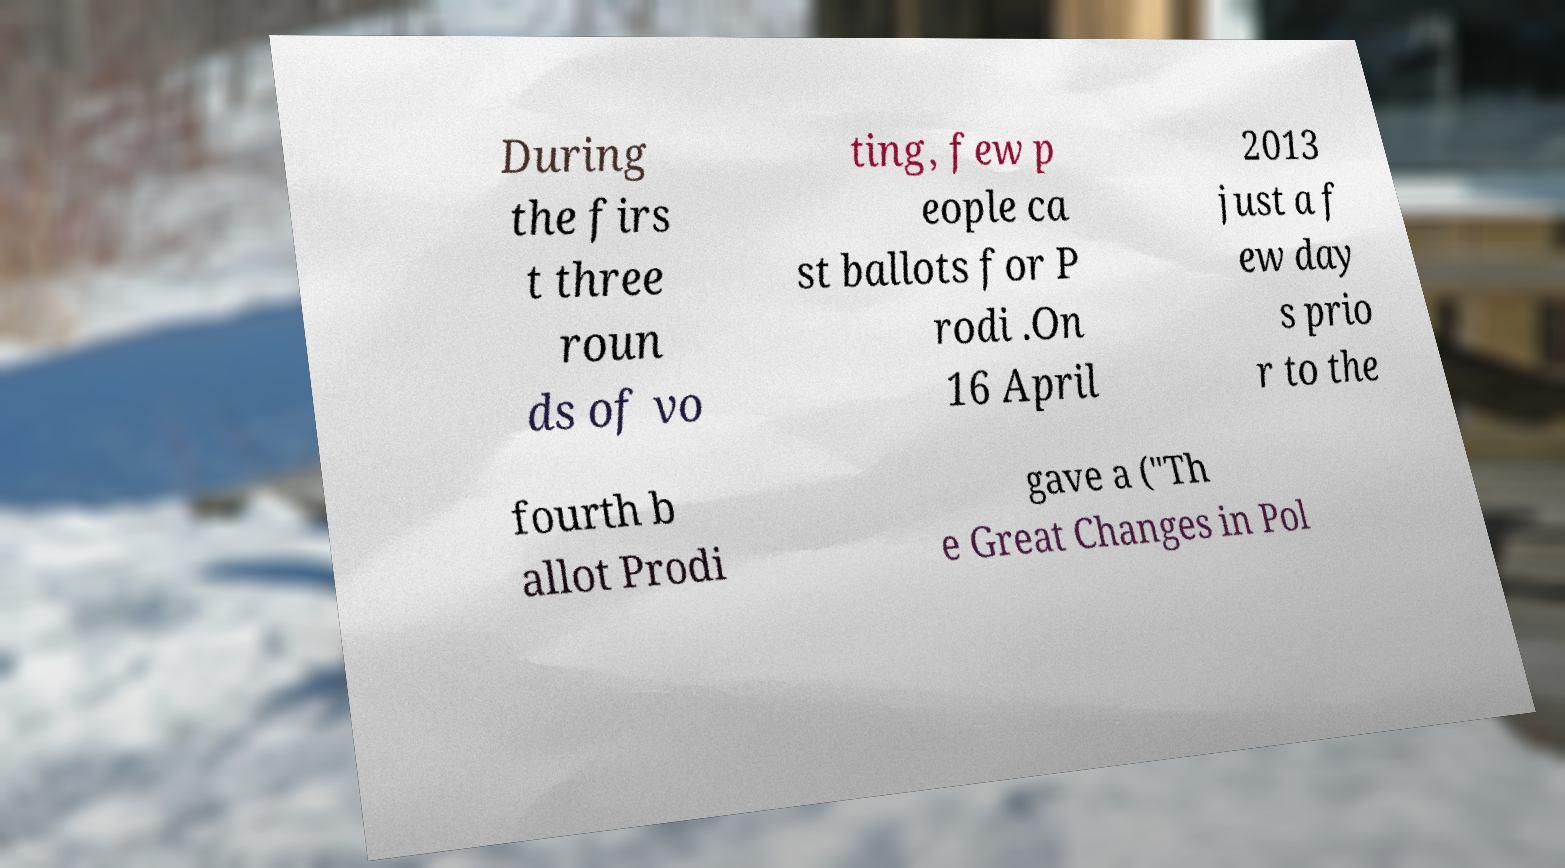Can you accurately transcribe the text from the provided image for me? During the firs t three roun ds of vo ting, few p eople ca st ballots for P rodi .On 16 April 2013 just a f ew day s prio r to the fourth b allot Prodi gave a ("Th e Great Changes in Pol 